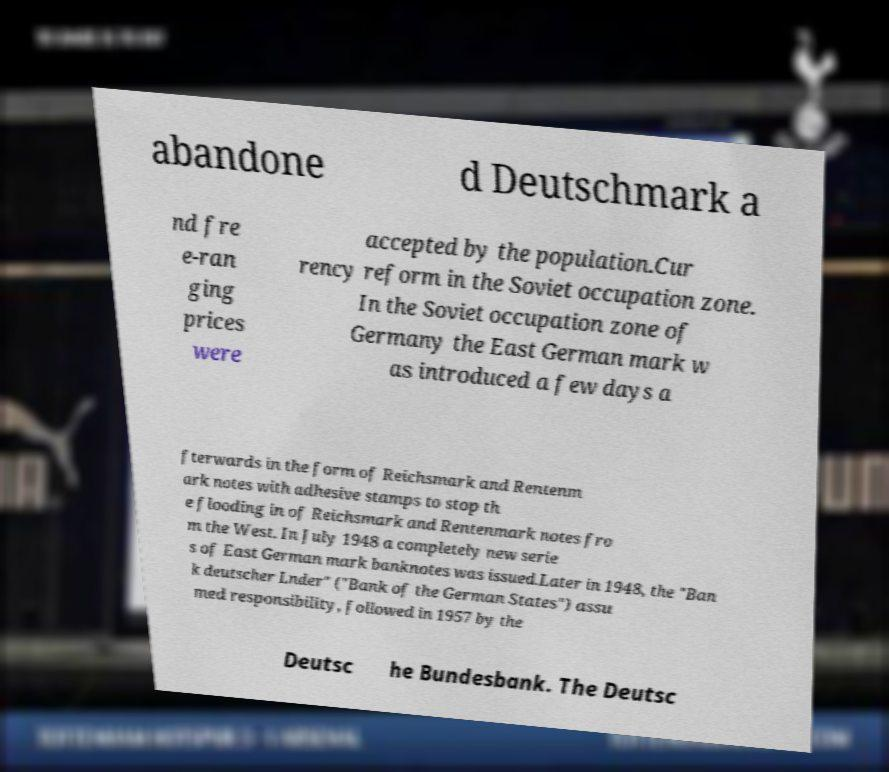Can you read and provide the text displayed in the image?This photo seems to have some interesting text. Can you extract and type it out for me? abandone d Deutschmark a nd fre e-ran ging prices were accepted by the population.Cur rency reform in the Soviet occupation zone. In the Soviet occupation zone of Germany the East German mark w as introduced a few days a fterwards in the form of Reichsmark and Rentenm ark notes with adhesive stamps to stop th e flooding in of Reichsmark and Rentenmark notes fro m the West. In July 1948 a completely new serie s of East German mark banknotes was issued.Later in 1948, the "Ban k deutscher Lnder" ("Bank of the German States") assu med responsibility, followed in 1957 by the Deutsc he Bundesbank. The Deutsc 